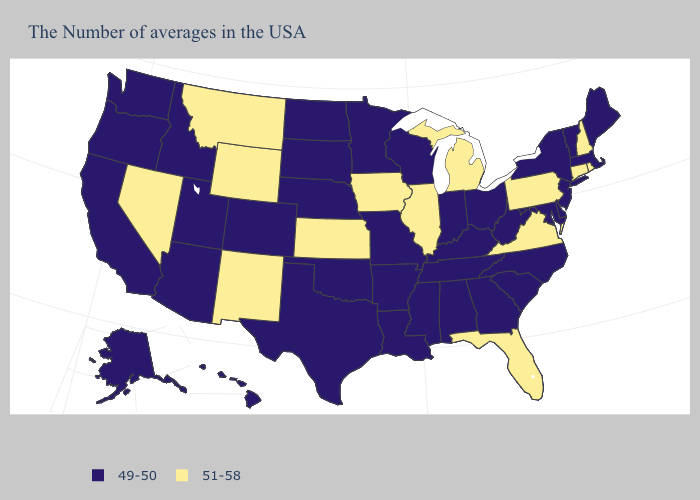What is the value of Maine?
Concise answer only. 49-50. Among the states that border Utah , does Colorado have the highest value?
Concise answer only. No. Among the states that border Alabama , which have the highest value?
Concise answer only. Florida. What is the value of Louisiana?
Give a very brief answer. 49-50. Which states have the lowest value in the West?
Answer briefly. Colorado, Utah, Arizona, Idaho, California, Washington, Oregon, Alaska, Hawaii. Which states hav the highest value in the West?
Give a very brief answer. Wyoming, New Mexico, Montana, Nevada. Which states have the highest value in the USA?
Answer briefly. Rhode Island, New Hampshire, Connecticut, Pennsylvania, Virginia, Florida, Michigan, Illinois, Iowa, Kansas, Wyoming, New Mexico, Montana, Nevada. Among the states that border South Carolina , which have the lowest value?
Short answer required. North Carolina, Georgia. Name the states that have a value in the range 49-50?
Give a very brief answer. Maine, Massachusetts, Vermont, New York, New Jersey, Delaware, Maryland, North Carolina, South Carolina, West Virginia, Ohio, Georgia, Kentucky, Indiana, Alabama, Tennessee, Wisconsin, Mississippi, Louisiana, Missouri, Arkansas, Minnesota, Nebraska, Oklahoma, Texas, South Dakota, North Dakota, Colorado, Utah, Arizona, Idaho, California, Washington, Oregon, Alaska, Hawaii. What is the lowest value in the Northeast?
Concise answer only. 49-50. Which states have the highest value in the USA?
Short answer required. Rhode Island, New Hampshire, Connecticut, Pennsylvania, Virginia, Florida, Michigan, Illinois, Iowa, Kansas, Wyoming, New Mexico, Montana, Nevada. Is the legend a continuous bar?
Keep it brief. No. What is the value of North Carolina?
Write a very short answer. 49-50. What is the lowest value in states that border Minnesota?
Give a very brief answer. 49-50. Does Hawaii have a lower value than Maryland?
Quick response, please. No. 